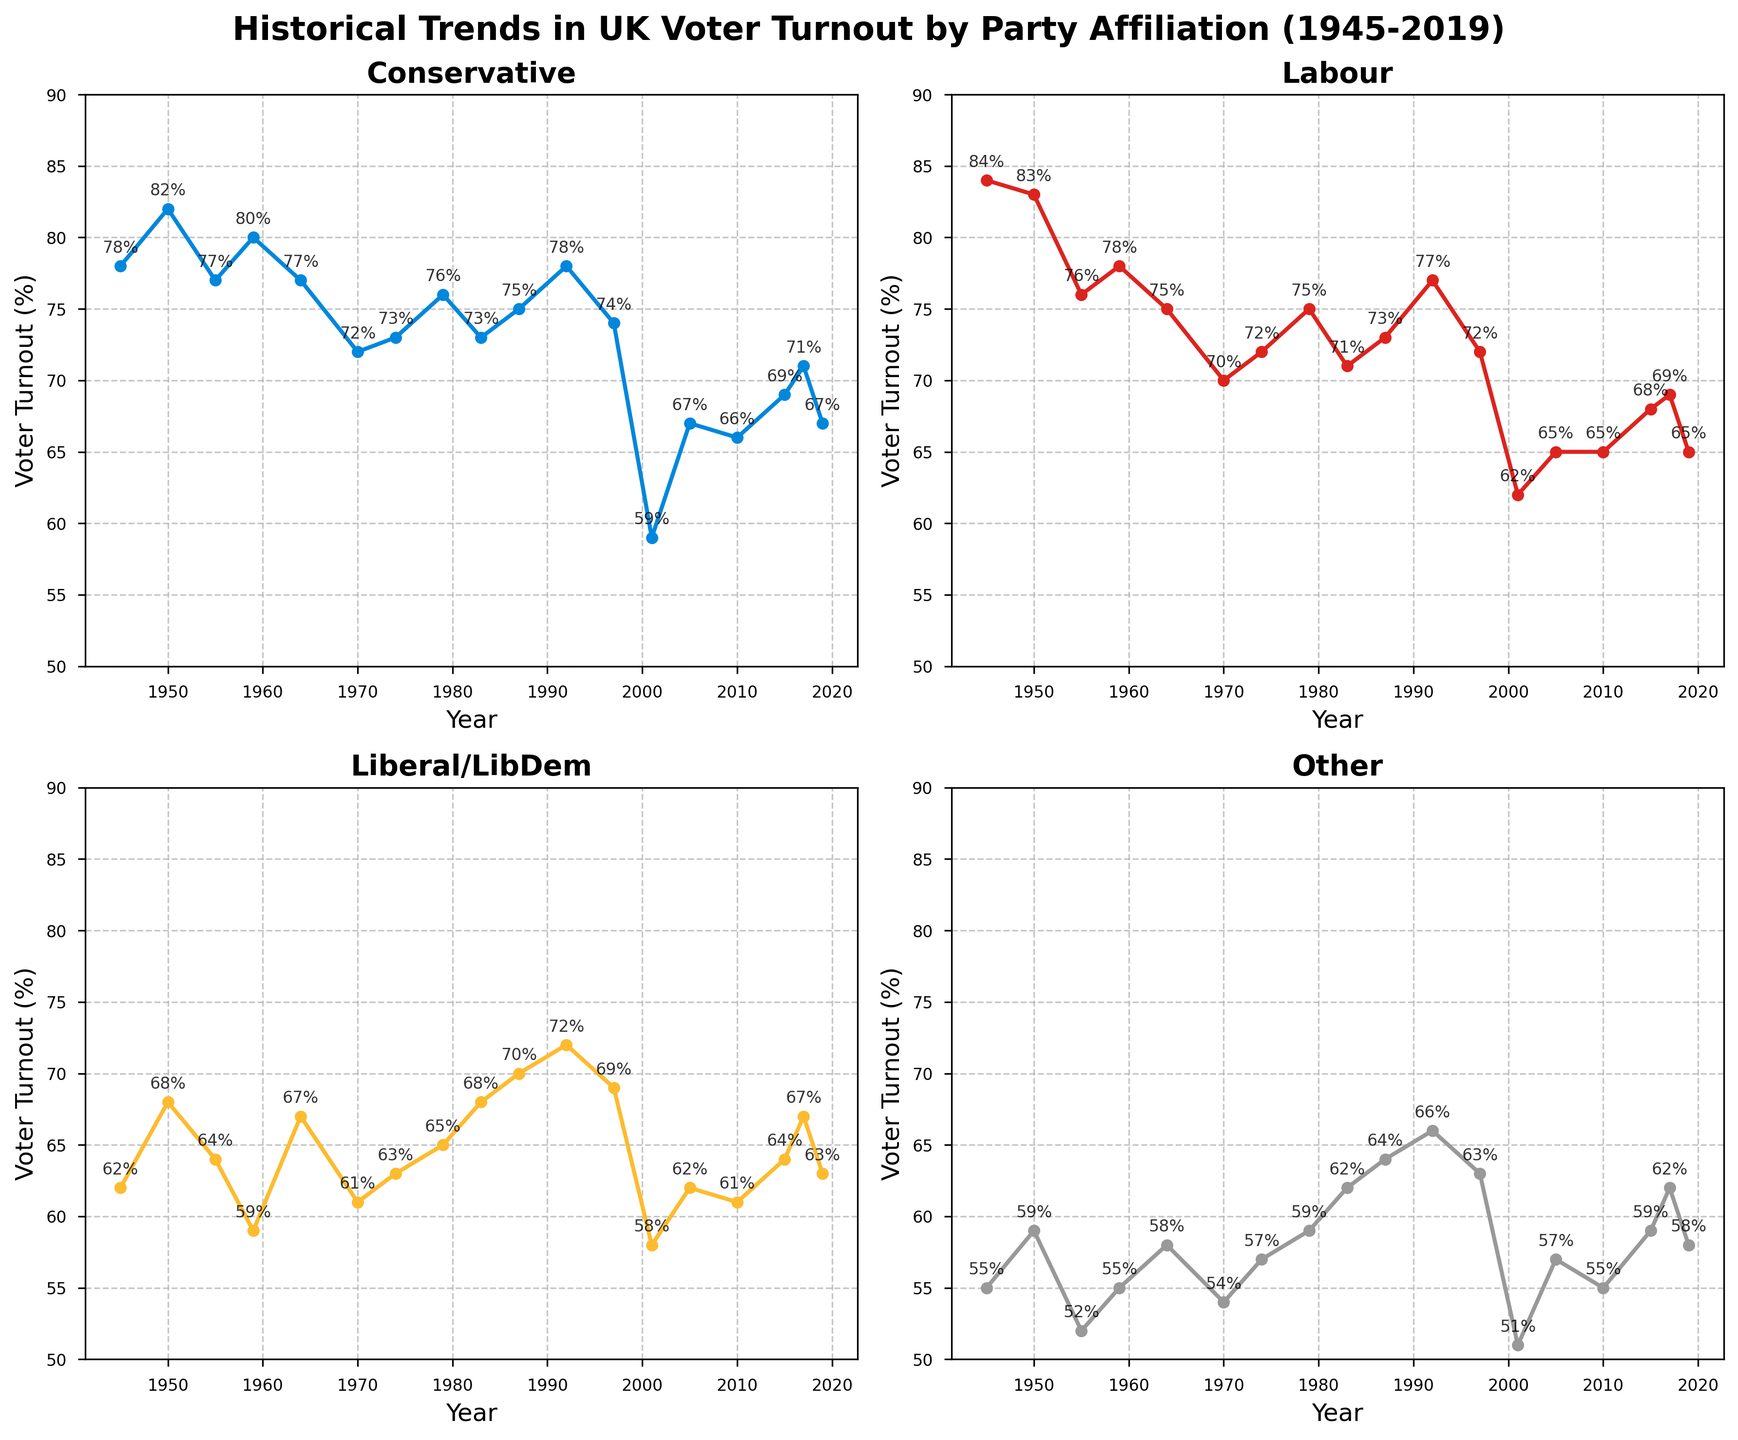What's the overall title of the figure? The overall title is found at the top of the figure, summarizing the content of the subplots. The title reads 'Historical Trends in UK Voter Turnout by Party Affiliation (1945-2019)'.
Answer: Historical Trends in UK Voter Turnout by Party Affiliation (1945-2019) How many subplots are in the figure? The figure contains four subplots, which can be seen from the layout showing four different segments, each labelled with a different party name.
Answer: 4 Which subplot shows the lowest voter turnout in 2001? We can visually inspect each subplot for the year 2001 and see the data points. The 'Conservative' subplot shows 59%, 'Labour' shows 62%, 'Liberal/LibDem' shows 58%, and 'Other' shows 51%.
Answer: Other In which year did the Conservative party have its highest voter turnout? In the 'Conservative' subplot, we look for the highest point on the line chart. The year is indicated at the x-axis, and the highest turnout is 82% in 1950.
Answer: 1950 What was Labour's voter turnout in 1992? In the 'Labour' subplot, look at the data point for the year 1992, which is labelled next to the point on the line. The value reads 77%.
Answer: 77% Which party had a voter turnout of 72% in the earliest year and which year was that? Checking each subplot, only the 'Labour' subplot shows a voter turnout of 72%, which occurred in 1950.
Answer: Labour, 1950 What is the average voter turnout for the Liberal/LibDem party across all years? Sum the voter turnout percentages for the Liberal/LibDem party: (62 + 68 + 64 + 59 + 67 + 61 + 63 + 65 + 68 + 70 + 72 + 69 + 58 + 62 + 61 + 64 + 67 + 63), which equals 1184. Then divide by the number of data points, which is 18. So, 1184 ÷ 18 = 65.78%.
Answer: 65.78% What trends are noticeable in the 'Other' party's voter turnout over the years? Observe the 'Other' subplot to analyze the trends: Between 1945 and 1950, there is a rise from 55% to 59%. Then, there is a general decline reaching the lowest in 2001 at 51%. This is followed by a gradual increase to 62% in 2017 and then a slight drop to 58% in 2019.
Answer: Initial rise, general decline, recent increase Compare the voter turnout trends between the Conservative and Labour parties from 1970 to 1997. Examining both subplots for the years 1970 to 1997: In 1970, Conservative turnout was 72% and Labour was 70%. By 1979, both parties saw increases (Conservative: 76%, Labour: 75%). Both experienced declines in 1983 (Conservative: 73%, Labour: 71%) but increased again by 1992 reaching peaks (Conservative: 78%, Labour: 77%). By 1997, both had somewhat similar declines (Conservative: 74%, Labour: 72%).
Answer: Both saw fluctuations with peaks in 1992 Which party saw the most significant drop in voter turnout between successive elections, and what were those years? Looking at each subplot for the steepest drops: The Labour party dropped from 77% in 1992 to 62% in 2001, a 15% drop in two successive elections.
Answer: Labour, 1992 to 2001 